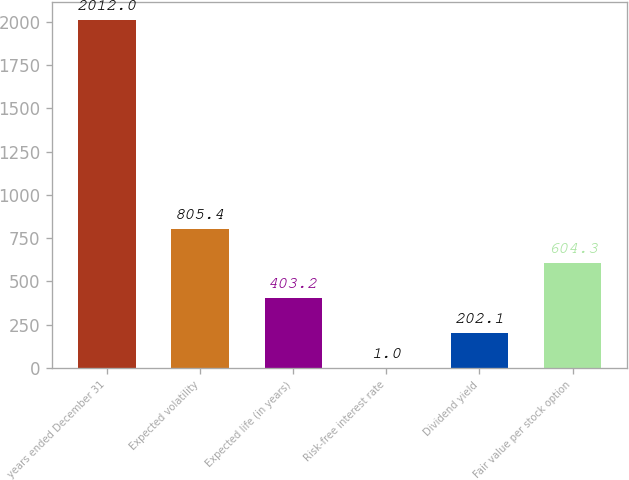<chart> <loc_0><loc_0><loc_500><loc_500><bar_chart><fcel>years ended December 31<fcel>Expected volatility<fcel>Expected life (in years)<fcel>Risk-free interest rate<fcel>Dividend yield<fcel>Fair value per stock option<nl><fcel>2012<fcel>805.4<fcel>403.2<fcel>1<fcel>202.1<fcel>604.3<nl></chart> 